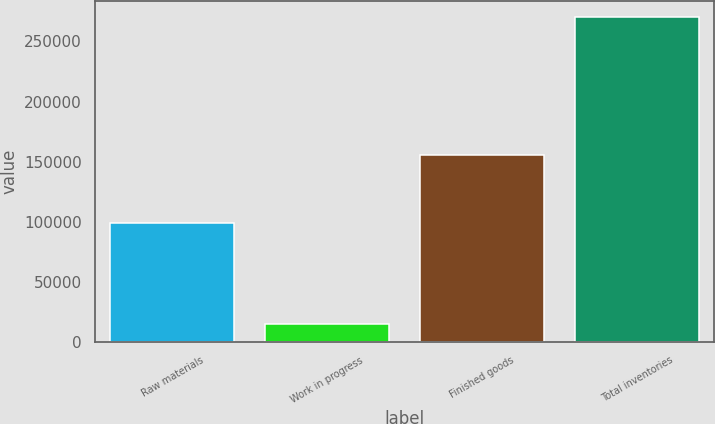Convert chart. <chart><loc_0><loc_0><loc_500><loc_500><bar_chart><fcel>Raw materials<fcel>Work in progress<fcel>Finished goods<fcel>Total inventories<nl><fcel>99033<fcel>15324<fcel>155937<fcel>270294<nl></chart> 